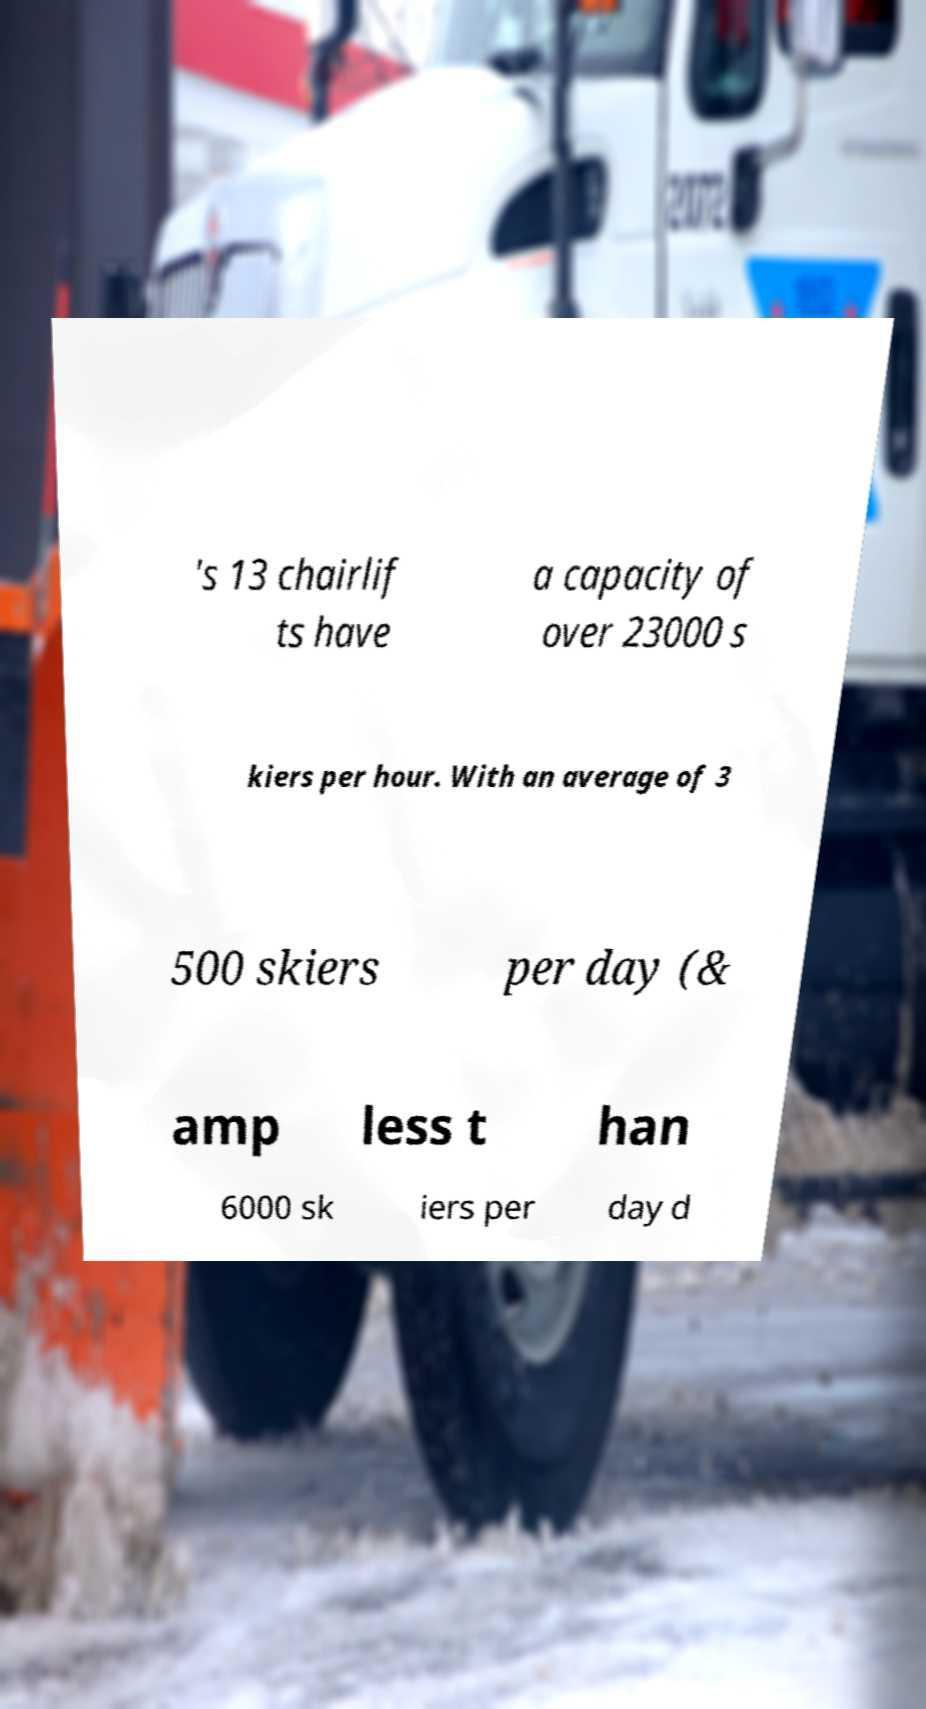Please identify and transcribe the text found in this image. 's 13 chairlif ts have a capacity of over 23000 s kiers per hour. With an average of 3 500 skiers per day (& amp less t han 6000 sk iers per day d 